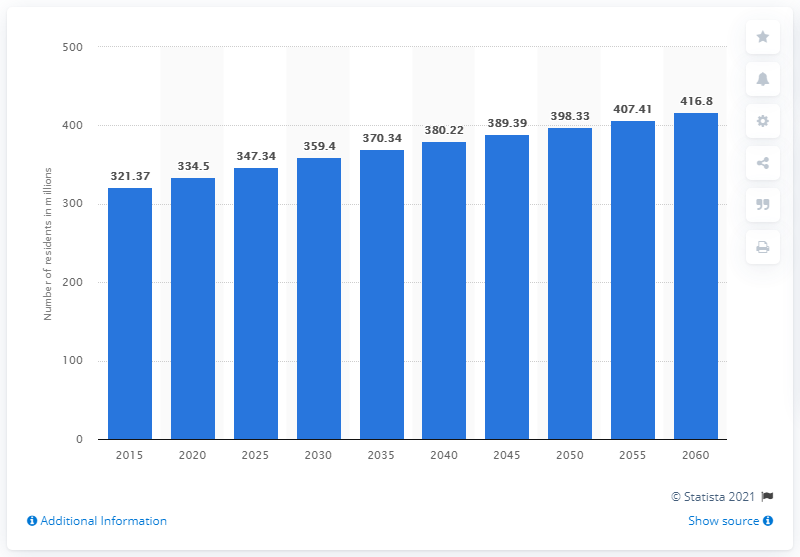Draw attention to some important aspects in this diagram. The sum of the value in 2055 and 2060 in the chart is 824.21. According to estimates, the population of the United States of America is expected to reach 398.33 mill In 2055, the blue bar crossed the 400 mark. 